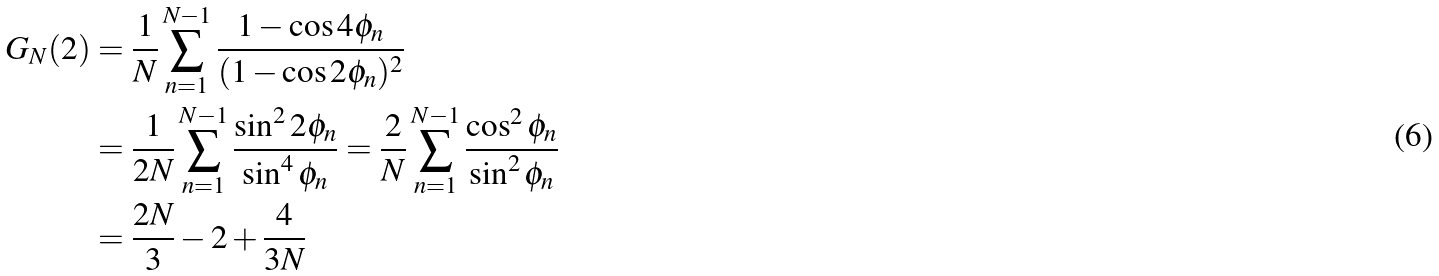Convert formula to latex. <formula><loc_0><loc_0><loc_500><loc_500>G _ { N } ( 2 ) & = \frac { 1 } { N } \sum ^ { N - 1 } _ { n = 1 } \frac { 1 - \cos 4 \phi _ { n } } { ( 1 - \cos 2 \phi _ { n } ) ^ { 2 } } \\ & = \frac { 1 } { 2 N } \sum ^ { N - 1 } _ { n = 1 } \frac { \sin ^ { 2 } 2 \phi _ { n } } { \sin ^ { 4 } \phi _ { n } } = \frac { 2 } { N } \sum ^ { N - 1 } _ { n = 1 } \frac { \cos ^ { 2 } \phi _ { n } } { \sin ^ { 2 } \phi _ { n } } \\ & = \frac { 2 N } { 3 } - 2 + \frac { 4 } { 3 N }</formula> 